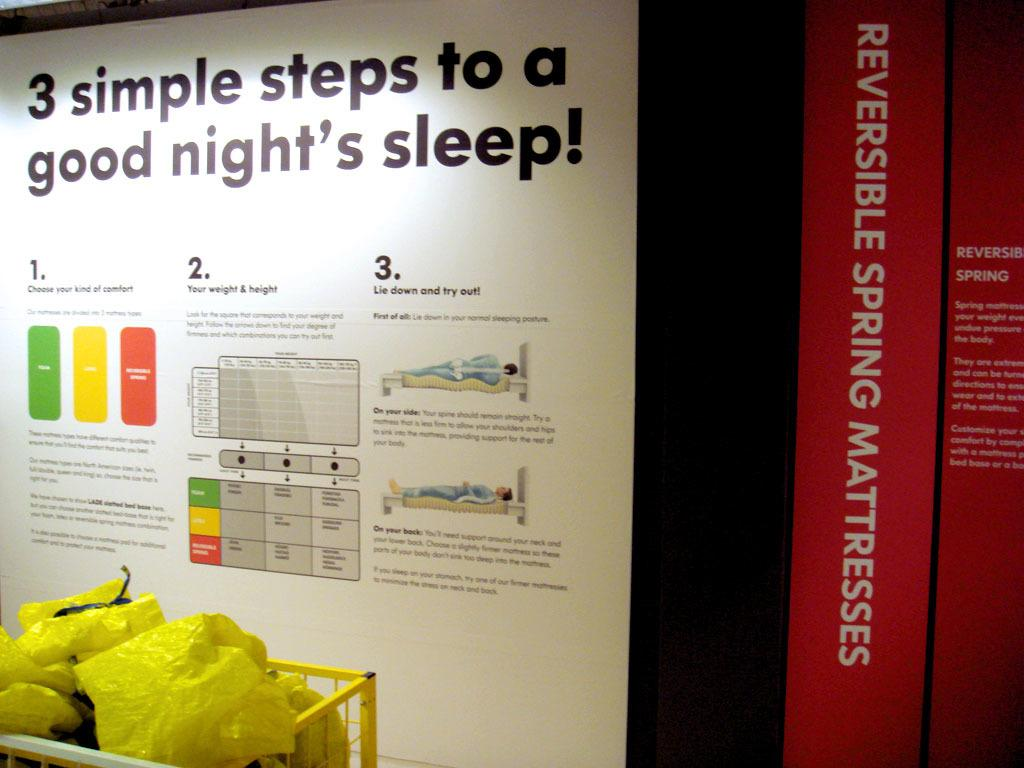<image>
Create a compact narrative representing the image presented. a chart for 3 simple steps to a good night's sleep! 